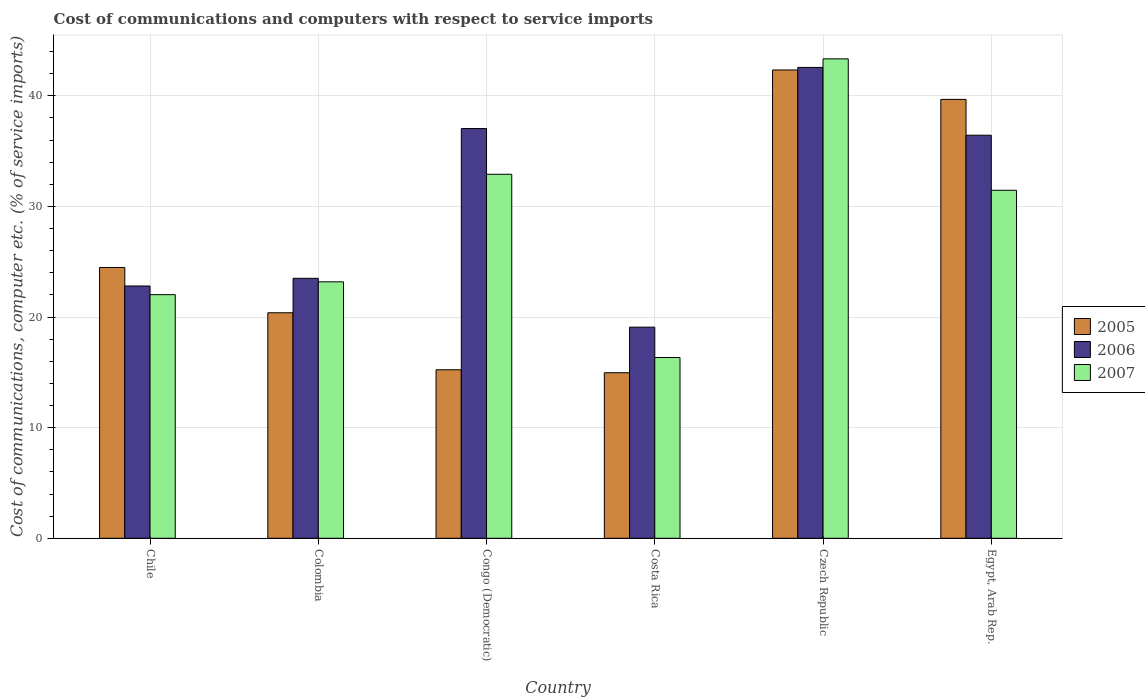How many groups of bars are there?
Keep it short and to the point. 6. Are the number of bars on each tick of the X-axis equal?
Offer a terse response. Yes. How many bars are there on the 6th tick from the left?
Give a very brief answer. 3. How many bars are there on the 1st tick from the right?
Your answer should be very brief. 3. In how many cases, is the number of bars for a given country not equal to the number of legend labels?
Offer a terse response. 0. What is the cost of communications and computers in 2007 in Costa Rica?
Your answer should be very brief. 16.34. Across all countries, what is the maximum cost of communications and computers in 2006?
Your answer should be very brief. 42.56. Across all countries, what is the minimum cost of communications and computers in 2007?
Keep it short and to the point. 16.34. In which country was the cost of communications and computers in 2005 maximum?
Offer a very short reply. Czech Republic. What is the total cost of communications and computers in 2006 in the graph?
Your answer should be compact. 181.43. What is the difference between the cost of communications and computers in 2007 in Congo (Democratic) and that in Costa Rica?
Offer a terse response. 16.56. What is the difference between the cost of communications and computers in 2007 in Congo (Democratic) and the cost of communications and computers in 2005 in Costa Rica?
Keep it short and to the point. 17.94. What is the average cost of communications and computers in 2007 per country?
Offer a very short reply. 28.21. What is the difference between the cost of communications and computers of/in 2007 and cost of communications and computers of/in 2006 in Congo (Democratic)?
Your response must be concise. -4.13. What is the ratio of the cost of communications and computers in 2006 in Colombia to that in Congo (Democratic)?
Provide a short and direct response. 0.63. What is the difference between the highest and the second highest cost of communications and computers in 2005?
Your response must be concise. -17.85. What is the difference between the highest and the lowest cost of communications and computers in 2006?
Your answer should be very brief. 23.48. In how many countries, is the cost of communications and computers in 2007 greater than the average cost of communications and computers in 2007 taken over all countries?
Keep it short and to the point. 3. What does the 1st bar from the left in Chile represents?
Offer a very short reply. 2005. What does the 1st bar from the right in Egypt, Arab Rep. represents?
Give a very brief answer. 2007. Is it the case that in every country, the sum of the cost of communications and computers in 2007 and cost of communications and computers in 2005 is greater than the cost of communications and computers in 2006?
Your response must be concise. Yes. How many bars are there?
Provide a succinct answer. 18. Are all the bars in the graph horizontal?
Provide a short and direct response. No. Are the values on the major ticks of Y-axis written in scientific E-notation?
Offer a very short reply. No. Does the graph contain any zero values?
Provide a short and direct response. No. Does the graph contain grids?
Provide a short and direct response. Yes. Where does the legend appear in the graph?
Provide a short and direct response. Center right. How many legend labels are there?
Keep it short and to the point. 3. What is the title of the graph?
Give a very brief answer. Cost of communications and computers with respect to service imports. What is the label or title of the Y-axis?
Make the answer very short. Cost of communications, computer etc. (% of service imports). What is the Cost of communications, computer etc. (% of service imports) of 2005 in Chile?
Your answer should be very brief. 24.48. What is the Cost of communications, computer etc. (% of service imports) in 2006 in Chile?
Provide a short and direct response. 22.81. What is the Cost of communications, computer etc. (% of service imports) of 2007 in Chile?
Your answer should be very brief. 22.02. What is the Cost of communications, computer etc. (% of service imports) of 2005 in Colombia?
Offer a very short reply. 20.39. What is the Cost of communications, computer etc. (% of service imports) of 2006 in Colombia?
Offer a very short reply. 23.5. What is the Cost of communications, computer etc. (% of service imports) of 2007 in Colombia?
Provide a short and direct response. 23.18. What is the Cost of communications, computer etc. (% of service imports) of 2005 in Congo (Democratic)?
Your answer should be very brief. 15.23. What is the Cost of communications, computer etc. (% of service imports) of 2006 in Congo (Democratic)?
Ensure brevity in your answer.  37.04. What is the Cost of communications, computer etc. (% of service imports) in 2007 in Congo (Democratic)?
Your answer should be very brief. 32.91. What is the Cost of communications, computer etc. (% of service imports) of 2005 in Costa Rica?
Your answer should be compact. 14.97. What is the Cost of communications, computer etc. (% of service imports) of 2006 in Costa Rica?
Keep it short and to the point. 19.09. What is the Cost of communications, computer etc. (% of service imports) in 2007 in Costa Rica?
Your answer should be compact. 16.34. What is the Cost of communications, computer etc. (% of service imports) in 2005 in Czech Republic?
Your response must be concise. 42.33. What is the Cost of communications, computer etc. (% of service imports) of 2006 in Czech Republic?
Make the answer very short. 42.56. What is the Cost of communications, computer etc. (% of service imports) of 2007 in Czech Republic?
Keep it short and to the point. 43.34. What is the Cost of communications, computer etc. (% of service imports) of 2005 in Egypt, Arab Rep.?
Keep it short and to the point. 39.68. What is the Cost of communications, computer etc. (% of service imports) in 2006 in Egypt, Arab Rep.?
Keep it short and to the point. 36.44. What is the Cost of communications, computer etc. (% of service imports) in 2007 in Egypt, Arab Rep.?
Your answer should be compact. 31.46. Across all countries, what is the maximum Cost of communications, computer etc. (% of service imports) in 2005?
Ensure brevity in your answer.  42.33. Across all countries, what is the maximum Cost of communications, computer etc. (% of service imports) of 2006?
Give a very brief answer. 42.56. Across all countries, what is the maximum Cost of communications, computer etc. (% of service imports) of 2007?
Provide a succinct answer. 43.34. Across all countries, what is the minimum Cost of communications, computer etc. (% of service imports) of 2005?
Offer a terse response. 14.97. Across all countries, what is the minimum Cost of communications, computer etc. (% of service imports) of 2006?
Keep it short and to the point. 19.09. Across all countries, what is the minimum Cost of communications, computer etc. (% of service imports) of 2007?
Your answer should be very brief. 16.34. What is the total Cost of communications, computer etc. (% of service imports) in 2005 in the graph?
Offer a very short reply. 157.08. What is the total Cost of communications, computer etc. (% of service imports) of 2006 in the graph?
Provide a succinct answer. 181.43. What is the total Cost of communications, computer etc. (% of service imports) in 2007 in the graph?
Keep it short and to the point. 169.26. What is the difference between the Cost of communications, computer etc. (% of service imports) of 2005 in Chile and that in Colombia?
Provide a short and direct response. 4.09. What is the difference between the Cost of communications, computer etc. (% of service imports) in 2006 in Chile and that in Colombia?
Provide a succinct answer. -0.69. What is the difference between the Cost of communications, computer etc. (% of service imports) in 2007 in Chile and that in Colombia?
Keep it short and to the point. -1.16. What is the difference between the Cost of communications, computer etc. (% of service imports) in 2005 in Chile and that in Congo (Democratic)?
Provide a succinct answer. 9.25. What is the difference between the Cost of communications, computer etc. (% of service imports) of 2006 in Chile and that in Congo (Democratic)?
Give a very brief answer. -14.23. What is the difference between the Cost of communications, computer etc. (% of service imports) in 2007 in Chile and that in Congo (Democratic)?
Your response must be concise. -10.88. What is the difference between the Cost of communications, computer etc. (% of service imports) of 2005 in Chile and that in Costa Rica?
Your answer should be very brief. 9.52. What is the difference between the Cost of communications, computer etc. (% of service imports) of 2006 in Chile and that in Costa Rica?
Give a very brief answer. 3.72. What is the difference between the Cost of communications, computer etc. (% of service imports) of 2007 in Chile and that in Costa Rica?
Offer a very short reply. 5.68. What is the difference between the Cost of communications, computer etc. (% of service imports) in 2005 in Chile and that in Czech Republic?
Offer a terse response. -17.85. What is the difference between the Cost of communications, computer etc. (% of service imports) of 2006 in Chile and that in Czech Republic?
Offer a terse response. -19.76. What is the difference between the Cost of communications, computer etc. (% of service imports) of 2007 in Chile and that in Czech Republic?
Give a very brief answer. -21.32. What is the difference between the Cost of communications, computer etc. (% of service imports) of 2005 in Chile and that in Egypt, Arab Rep.?
Ensure brevity in your answer.  -15.19. What is the difference between the Cost of communications, computer etc. (% of service imports) in 2006 in Chile and that in Egypt, Arab Rep.?
Offer a terse response. -13.63. What is the difference between the Cost of communications, computer etc. (% of service imports) of 2007 in Chile and that in Egypt, Arab Rep.?
Your answer should be very brief. -9.44. What is the difference between the Cost of communications, computer etc. (% of service imports) in 2005 in Colombia and that in Congo (Democratic)?
Offer a terse response. 5.15. What is the difference between the Cost of communications, computer etc. (% of service imports) in 2006 in Colombia and that in Congo (Democratic)?
Make the answer very short. -13.54. What is the difference between the Cost of communications, computer etc. (% of service imports) of 2007 in Colombia and that in Congo (Democratic)?
Provide a short and direct response. -9.72. What is the difference between the Cost of communications, computer etc. (% of service imports) of 2005 in Colombia and that in Costa Rica?
Make the answer very short. 5.42. What is the difference between the Cost of communications, computer etc. (% of service imports) of 2006 in Colombia and that in Costa Rica?
Give a very brief answer. 4.41. What is the difference between the Cost of communications, computer etc. (% of service imports) in 2007 in Colombia and that in Costa Rica?
Give a very brief answer. 6.84. What is the difference between the Cost of communications, computer etc. (% of service imports) of 2005 in Colombia and that in Czech Republic?
Give a very brief answer. -21.95. What is the difference between the Cost of communications, computer etc. (% of service imports) in 2006 in Colombia and that in Czech Republic?
Ensure brevity in your answer.  -19.06. What is the difference between the Cost of communications, computer etc. (% of service imports) of 2007 in Colombia and that in Czech Republic?
Your response must be concise. -20.16. What is the difference between the Cost of communications, computer etc. (% of service imports) in 2005 in Colombia and that in Egypt, Arab Rep.?
Your answer should be compact. -19.29. What is the difference between the Cost of communications, computer etc. (% of service imports) of 2006 in Colombia and that in Egypt, Arab Rep.?
Make the answer very short. -12.94. What is the difference between the Cost of communications, computer etc. (% of service imports) in 2007 in Colombia and that in Egypt, Arab Rep.?
Your answer should be very brief. -8.28. What is the difference between the Cost of communications, computer etc. (% of service imports) in 2005 in Congo (Democratic) and that in Costa Rica?
Offer a terse response. 0.27. What is the difference between the Cost of communications, computer etc. (% of service imports) in 2006 in Congo (Democratic) and that in Costa Rica?
Offer a terse response. 17.95. What is the difference between the Cost of communications, computer etc. (% of service imports) of 2007 in Congo (Democratic) and that in Costa Rica?
Keep it short and to the point. 16.56. What is the difference between the Cost of communications, computer etc. (% of service imports) in 2005 in Congo (Democratic) and that in Czech Republic?
Provide a succinct answer. -27.1. What is the difference between the Cost of communications, computer etc. (% of service imports) of 2006 in Congo (Democratic) and that in Czech Republic?
Provide a short and direct response. -5.53. What is the difference between the Cost of communications, computer etc. (% of service imports) of 2007 in Congo (Democratic) and that in Czech Republic?
Offer a very short reply. -10.43. What is the difference between the Cost of communications, computer etc. (% of service imports) in 2005 in Congo (Democratic) and that in Egypt, Arab Rep.?
Provide a succinct answer. -24.44. What is the difference between the Cost of communications, computer etc. (% of service imports) of 2006 in Congo (Democratic) and that in Egypt, Arab Rep.?
Your response must be concise. 0.6. What is the difference between the Cost of communications, computer etc. (% of service imports) in 2007 in Congo (Democratic) and that in Egypt, Arab Rep.?
Your answer should be very brief. 1.45. What is the difference between the Cost of communications, computer etc. (% of service imports) in 2005 in Costa Rica and that in Czech Republic?
Keep it short and to the point. -27.37. What is the difference between the Cost of communications, computer etc. (% of service imports) in 2006 in Costa Rica and that in Czech Republic?
Make the answer very short. -23.48. What is the difference between the Cost of communications, computer etc. (% of service imports) of 2007 in Costa Rica and that in Czech Republic?
Your response must be concise. -27. What is the difference between the Cost of communications, computer etc. (% of service imports) in 2005 in Costa Rica and that in Egypt, Arab Rep.?
Your answer should be compact. -24.71. What is the difference between the Cost of communications, computer etc. (% of service imports) of 2006 in Costa Rica and that in Egypt, Arab Rep.?
Your response must be concise. -17.35. What is the difference between the Cost of communications, computer etc. (% of service imports) of 2007 in Costa Rica and that in Egypt, Arab Rep.?
Your response must be concise. -15.12. What is the difference between the Cost of communications, computer etc. (% of service imports) of 2005 in Czech Republic and that in Egypt, Arab Rep.?
Ensure brevity in your answer.  2.66. What is the difference between the Cost of communications, computer etc. (% of service imports) in 2006 in Czech Republic and that in Egypt, Arab Rep.?
Ensure brevity in your answer.  6.13. What is the difference between the Cost of communications, computer etc. (% of service imports) of 2007 in Czech Republic and that in Egypt, Arab Rep.?
Keep it short and to the point. 11.88. What is the difference between the Cost of communications, computer etc. (% of service imports) in 2005 in Chile and the Cost of communications, computer etc. (% of service imports) in 2006 in Colombia?
Provide a succinct answer. 0.98. What is the difference between the Cost of communications, computer etc. (% of service imports) of 2005 in Chile and the Cost of communications, computer etc. (% of service imports) of 2007 in Colombia?
Offer a terse response. 1.3. What is the difference between the Cost of communications, computer etc. (% of service imports) in 2006 in Chile and the Cost of communications, computer etc. (% of service imports) in 2007 in Colombia?
Provide a short and direct response. -0.38. What is the difference between the Cost of communications, computer etc. (% of service imports) in 2005 in Chile and the Cost of communications, computer etc. (% of service imports) in 2006 in Congo (Democratic)?
Offer a terse response. -12.56. What is the difference between the Cost of communications, computer etc. (% of service imports) in 2005 in Chile and the Cost of communications, computer etc. (% of service imports) in 2007 in Congo (Democratic)?
Provide a short and direct response. -8.43. What is the difference between the Cost of communications, computer etc. (% of service imports) in 2006 in Chile and the Cost of communications, computer etc. (% of service imports) in 2007 in Congo (Democratic)?
Provide a succinct answer. -10.1. What is the difference between the Cost of communications, computer etc. (% of service imports) in 2005 in Chile and the Cost of communications, computer etc. (% of service imports) in 2006 in Costa Rica?
Your answer should be compact. 5.4. What is the difference between the Cost of communications, computer etc. (% of service imports) of 2005 in Chile and the Cost of communications, computer etc. (% of service imports) of 2007 in Costa Rica?
Offer a terse response. 8.14. What is the difference between the Cost of communications, computer etc. (% of service imports) in 2006 in Chile and the Cost of communications, computer etc. (% of service imports) in 2007 in Costa Rica?
Your response must be concise. 6.46. What is the difference between the Cost of communications, computer etc. (% of service imports) in 2005 in Chile and the Cost of communications, computer etc. (% of service imports) in 2006 in Czech Republic?
Give a very brief answer. -18.08. What is the difference between the Cost of communications, computer etc. (% of service imports) of 2005 in Chile and the Cost of communications, computer etc. (% of service imports) of 2007 in Czech Republic?
Provide a succinct answer. -18.86. What is the difference between the Cost of communications, computer etc. (% of service imports) in 2006 in Chile and the Cost of communications, computer etc. (% of service imports) in 2007 in Czech Republic?
Your answer should be compact. -20.53. What is the difference between the Cost of communications, computer etc. (% of service imports) in 2005 in Chile and the Cost of communications, computer etc. (% of service imports) in 2006 in Egypt, Arab Rep.?
Provide a succinct answer. -11.96. What is the difference between the Cost of communications, computer etc. (% of service imports) in 2005 in Chile and the Cost of communications, computer etc. (% of service imports) in 2007 in Egypt, Arab Rep.?
Your answer should be compact. -6.98. What is the difference between the Cost of communications, computer etc. (% of service imports) of 2006 in Chile and the Cost of communications, computer etc. (% of service imports) of 2007 in Egypt, Arab Rep.?
Your answer should be compact. -8.65. What is the difference between the Cost of communications, computer etc. (% of service imports) of 2005 in Colombia and the Cost of communications, computer etc. (% of service imports) of 2006 in Congo (Democratic)?
Ensure brevity in your answer.  -16.65. What is the difference between the Cost of communications, computer etc. (% of service imports) of 2005 in Colombia and the Cost of communications, computer etc. (% of service imports) of 2007 in Congo (Democratic)?
Offer a terse response. -12.52. What is the difference between the Cost of communications, computer etc. (% of service imports) of 2006 in Colombia and the Cost of communications, computer etc. (% of service imports) of 2007 in Congo (Democratic)?
Keep it short and to the point. -9.41. What is the difference between the Cost of communications, computer etc. (% of service imports) in 2005 in Colombia and the Cost of communications, computer etc. (% of service imports) in 2006 in Costa Rica?
Ensure brevity in your answer.  1.3. What is the difference between the Cost of communications, computer etc. (% of service imports) in 2005 in Colombia and the Cost of communications, computer etc. (% of service imports) in 2007 in Costa Rica?
Give a very brief answer. 4.04. What is the difference between the Cost of communications, computer etc. (% of service imports) in 2006 in Colombia and the Cost of communications, computer etc. (% of service imports) in 2007 in Costa Rica?
Your answer should be very brief. 7.16. What is the difference between the Cost of communications, computer etc. (% of service imports) in 2005 in Colombia and the Cost of communications, computer etc. (% of service imports) in 2006 in Czech Republic?
Make the answer very short. -22.18. What is the difference between the Cost of communications, computer etc. (% of service imports) of 2005 in Colombia and the Cost of communications, computer etc. (% of service imports) of 2007 in Czech Republic?
Ensure brevity in your answer.  -22.95. What is the difference between the Cost of communications, computer etc. (% of service imports) in 2006 in Colombia and the Cost of communications, computer etc. (% of service imports) in 2007 in Czech Republic?
Your answer should be very brief. -19.84. What is the difference between the Cost of communications, computer etc. (% of service imports) in 2005 in Colombia and the Cost of communications, computer etc. (% of service imports) in 2006 in Egypt, Arab Rep.?
Give a very brief answer. -16.05. What is the difference between the Cost of communications, computer etc. (% of service imports) of 2005 in Colombia and the Cost of communications, computer etc. (% of service imports) of 2007 in Egypt, Arab Rep.?
Your answer should be very brief. -11.07. What is the difference between the Cost of communications, computer etc. (% of service imports) in 2006 in Colombia and the Cost of communications, computer etc. (% of service imports) in 2007 in Egypt, Arab Rep.?
Your response must be concise. -7.96. What is the difference between the Cost of communications, computer etc. (% of service imports) in 2005 in Congo (Democratic) and the Cost of communications, computer etc. (% of service imports) in 2006 in Costa Rica?
Your answer should be compact. -3.85. What is the difference between the Cost of communications, computer etc. (% of service imports) of 2005 in Congo (Democratic) and the Cost of communications, computer etc. (% of service imports) of 2007 in Costa Rica?
Keep it short and to the point. -1.11. What is the difference between the Cost of communications, computer etc. (% of service imports) in 2006 in Congo (Democratic) and the Cost of communications, computer etc. (% of service imports) in 2007 in Costa Rica?
Provide a succinct answer. 20.7. What is the difference between the Cost of communications, computer etc. (% of service imports) of 2005 in Congo (Democratic) and the Cost of communications, computer etc. (% of service imports) of 2006 in Czech Republic?
Your answer should be compact. -27.33. What is the difference between the Cost of communications, computer etc. (% of service imports) of 2005 in Congo (Democratic) and the Cost of communications, computer etc. (% of service imports) of 2007 in Czech Republic?
Ensure brevity in your answer.  -28.11. What is the difference between the Cost of communications, computer etc. (% of service imports) of 2006 in Congo (Democratic) and the Cost of communications, computer etc. (% of service imports) of 2007 in Czech Republic?
Your answer should be very brief. -6.3. What is the difference between the Cost of communications, computer etc. (% of service imports) in 2005 in Congo (Democratic) and the Cost of communications, computer etc. (% of service imports) in 2006 in Egypt, Arab Rep.?
Keep it short and to the point. -21.2. What is the difference between the Cost of communications, computer etc. (% of service imports) of 2005 in Congo (Democratic) and the Cost of communications, computer etc. (% of service imports) of 2007 in Egypt, Arab Rep.?
Give a very brief answer. -16.23. What is the difference between the Cost of communications, computer etc. (% of service imports) of 2006 in Congo (Democratic) and the Cost of communications, computer etc. (% of service imports) of 2007 in Egypt, Arab Rep.?
Ensure brevity in your answer.  5.58. What is the difference between the Cost of communications, computer etc. (% of service imports) in 2005 in Costa Rica and the Cost of communications, computer etc. (% of service imports) in 2006 in Czech Republic?
Your response must be concise. -27.6. What is the difference between the Cost of communications, computer etc. (% of service imports) in 2005 in Costa Rica and the Cost of communications, computer etc. (% of service imports) in 2007 in Czech Republic?
Offer a very short reply. -28.38. What is the difference between the Cost of communications, computer etc. (% of service imports) of 2006 in Costa Rica and the Cost of communications, computer etc. (% of service imports) of 2007 in Czech Republic?
Offer a very short reply. -24.26. What is the difference between the Cost of communications, computer etc. (% of service imports) in 2005 in Costa Rica and the Cost of communications, computer etc. (% of service imports) in 2006 in Egypt, Arab Rep.?
Provide a short and direct response. -21.47. What is the difference between the Cost of communications, computer etc. (% of service imports) in 2005 in Costa Rica and the Cost of communications, computer etc. (% of service imports) in 2007 in Egypt, Arab Rep.?
Your answer should be compact. -16.49. What is the difference between the Cost of communications, computer etc. (% of service imports) in 2006 in Costa Rica and the Cost of communications, computer etc. (% of service imports) in 2007 in Egypt, Arab Rep.?
Ensure brevity in your answer.  -12.37. What is the difference between the Cost of communications, computer etc. (% of service imports) in 2005 in Czech Republic and the Cost of communications, computer etc. (% of service imports) in 2006 in Egypt, Arab Rep.?
Ensure brevity in your answer.  5.9. What is the difference between the Cost of communications, computer etc. (% of service imports) in 2005 in Czech Republic and the Cost of communications, computer etc. (% of service imports) in 2007 in Egypt, Arab Rep.?
Make the answer very short. 10.88. What is the difference between the Cost of communications, computer etc. (% of service imports) of 2006 in Czech Republic and the Cost of communications, computer etc. (% of service imports) of 2007 in Egypt, Arab Rep.?
Ensure brevity in your answer.  11.1. What is the average Cost of communications, computer etc. (% of service imports) in 2005 per country?
Your answer should be very brief. 26.18. What is the average Cost of communications, computer etc. (% of service imports) in 2006 per country?
Offer a very short reply. 30.24. What is the average Cost of communications, computer etc. (% of service imports) of 2007 per country?
Ensure brevity in your answer.  28.21. What is the difference between the Cost of communications, computer etc. (% of service imports) of 2005 and Cost of communications, computer etc. (% of service imports) of 2006 in Chile?
Keep it short and to the point. 1.67. What is the difference between the Cost of communications, computer etc. (% of service imports) in 2005 and Cost of communications, computer etc. (% of service imports) in 2007 in Chile?
Offer a very short reply. 2.46. What is the difference between the Cost of communications, computer etc. (% of service imports) of 2006 and Cost of communications, computer etc. (% of service imports) of 2007 in Chile?
Offer a terse response. 0.78. What is the difference between the Cost of communications, computer etc. (% of service imports) in 2005 and Cost of communications, computer etc. (% of service imports) in 2006 in Colombia?
Offer a terse response. -3.11. What is the difference between the Cost of communications, computer etc. (% of service imports) in 2005 and Cost of communications, computer etc. (% of service imports) in 2007 in Colombia?
Offer a terse response. -2.8. What is the difference between the Cost of communications, computer etc. (% of service imports) of 2006 and Cost of communications, computer etc. (% of service imports) of 2007 in Colombia?
Keep it short and to the point. 0.32. What is the difference between the Cost of communications, computer etc. (% of service imports) in 2005 and Cost of communications, computer etc. (% of service imports) in 2006 in Congo (Democratic)?
Provide a short and direct response. -21.81. What is the difference between the Cost of communications, computer etc. (% of service imports) in 2005 and Cost of communications, computer etc. (% of service imports) in 2007 in Congo (Democratic)?
Give a very brief answer. -17.67. What is the difference between the Cost of communications, computer etc. (% of service imports) of 2006 and Cost of communications, computer etc. (% of service imports) of 2007 in Congo (Democratic)?
Make the answer very short. 4.13. What is the difference between the Cost of communications, computer etc. (% of service imports) in 2005 and Cost of communications, computer etc. (% of service imports) in 2006 in Costa Rica?
Your answer should be compact. -4.12. What is the difference between the Cost of communications, computer etc. (% of service imports) in 2005 and Cost of communications, computer etc. (% of service imports) in 2007 in Costa Rica?
Your answer should be compact. -1.38. What is the difference between the Cost of communications, computer etc. (% of service imports) of 2006 and Cost of communications, computer etc. (% of service imports) of 2007 in Costa Rica?
Offer a very short reply. 2.74. What is the difference between the Cost of communications, computer etc. (% of service imports) of 2005 and Cost of communications, computer etc. (% of service imports) of 2006 in Czech Republic?
Provide a succinct answer. -0.23. What is the difference between the Cost of communications, computer etc. (% of service imports) in 2005 and Cost of communications, computer etc. (% of service imports) in 2007 in Czech Republic?
Provide a succinct answer. -1.01. What is the difference between the Cost of communications, computer etc. (% of service imports) in 2006 and Cost of communications, computer etc. (% of service imports) in 2007 in Czech Republic?
Make the answer very short. -0.78. What is the difference between the Cost of communications, computer etc. (% of service imports) in 2005 and Cost of communications, computer etc. (% of service imports) in 2006 in Egypt, Arab Rep.?
Keep it short and to the point. 3.24. What is the difference between the Cost of communications, computer etc. (% of service imports) in 2005 and Cost of communications, computer etc. (% of service imports) in 2007 in Egypt, Arab Rep.?
Your answer should be very brief. 8.22. What is the difference between the Cost of communications, computer etc. (% of service imports) in 2006 and Cost of communications, computer etc. (% of service imports) in 2007 in Egypt, Arab Rep.?
Give a very brief answer. 4.98. What is the ratio of the Cost of communications, computer etc. (% of service imports) in 2005 in Chile to that in Colombia?
Offer a terse response. 1.2. What is the ratio of the Cost of communications, computer etc. (% of service imports) of 2006 in Chile to that in Colombia?
Ensure brevity in your answer.  0.97. What is the ratio of the Cost of communications, computer etc. (% of service imports) in 2005 in Chile to that in Congo (Democratic)?
Give a very brief answer. 1.61. What is the ratio of the Cost of communications, computer etc. (% of service imports) in 2006 in Chile to that in Congo (Democratic)?
Your response must be concise. 0.62. What is the ratio of the Cost of communications, computer etc. (% of service imports) of 2007 in Chile to that in Congo (Democratic)?
Offer a terse response. 0.67. What is the ratio of the Cost of communications, computer etc. (% of service imports) in 2005 in Chile to that in Costa Rica?
Keep it short and to the point. 1.64. What is the ratio of the Cost of communications, computer etc. (% of service imports) of 2006 in Chile to that in Costa Rica?
Provide a succinct answer. 1.2. What is the ratio of the Cost of communications, computer etc. (% of service imports) in 2007 in Chile to that in Costa Rica?
Provide a short and direct response. 1.35. What is the ratio of the Cost of communications, computer etc. (% of service imports) in 2005 in Chile to that in Czech Republic?
Your answer should be very brief. 0.58. What is the ratio of the Cost of communications, computer etc. (% of service imports) in 2006 in Chile to that in Czech Republic?
Offer a terse response. 0.54. What is the ratio of the Cost of communications, computer etc. (% of service imports) of 2007 in Chile to that in Czech Republic?
Give a very brief answer. 0.51. What is the ratio of the Cost of communications, computer etc. (% of service imports) of 2005 in Chile to that in Egypt, Arab Rep.?
Offer a terse response. 0.62. What is the ratio of the Cost of communications, computer etc. (% of service imports) of 2006 in Chile to that in Egypt, Arab Rep.?
Your response must be concise. 0.63. What is the ratio of the Cost of communications, computer etc. (% of service imports) in 2007 in Chile to that in Egypt, Arab Rep.?
Your answer should be very brief. 0.7. What is the ratio of the Cost of communications, computer etc. (% of service imports) in 2005 in Colombia to that in Congo (Democratic)?
Ensure brevity in your answer.  1.34. What is the ratio of the Cost of communications, computer etc. (% of service imports) of 2006 in Colombia to that in Congo (Democratic)?
Make the answer very short. 0.63. What is the ratio of the Cost of communications, computer etc. (% of service imports) in 2007 in Colombia to that in Congo (Democratic)?
Ensure brevity in your answer.  0.7. What is the ratio of the Cost of communications, computer etc. (% of service imports) of 2005 in Colombia to that in Costa Rica?
Make the answer very short. 1.36. What is the ratio of the Cost of communications, computer etc. (% of service imports) in 2006 in Colombia to that in Costa Rica?
Your answer should be very brief. 1.23. What is the ratio of the Cost of communications, computer etc. (% of service imports) of 2007 in Colombia to that in Costa Rica?
Give a very brief answer. 1.42. What is the ratio of the Cost of communications, computer etc. (% of service imports) in 2005 in Colombia to that in Czech Republic?
Your answer should be compact. 0.48. What is the ratio of the Cost of communications, computer etc. (% of service imports) of 2006 in Colombia to that in Czech Republic?
Keep it short and to the point. 0.55. What is the ratio of the Cost of communications, computer etc. (% of service imports) of 2007 in Colombia to that in Czech Republic?
Make the answer very short. 0.53. What is the ratio of the Cost of communications, computer etc. (% of service imports) of 2005 in Colombia to that in Egypt, Arab Rep.?
Your answer should be very brief. 0.51. What is the ratio of the Cost of communications, computer etc. (% of service imports) of 2006 in Colombia to that in Egypt, Arab Rep.?
Keep it short and to the point. 0.64. What is the ratio of the Cost of communications, computer etc. (% of service imports) in 2007 in Colombia to that in Egypt, Arab Rep.?
Ensure brevity in your answer.  0.74. What is the ratio of the Cost of communications, computer etc. (% of service imports) of 2005 in Congo (Democratic) to that in Costa Rica?
Ensure brevity in your answer.  1.02. What is the ratio of the Cost of communications, computer etc. (% of service imports) in 2006 in Congo (Democratic) to that in Costa Rica?
Offer a very short reply. 1.94. What is the ratio of the Cost of communications, computer etc. (% of service imports) in 2007 in Congo (Democratic) to that in Costa Rica?
Make the answer very short. 2.01. What is the ratio of the Cost of communications, computer etc. (% of service imports) of 2005 in Congo (Democratic) to that in Czech Republic?
Offer a terse response. 0.36. What is the ratio of the Cost of communications, computer etc. (% of service imports) in 2006 in Congo (Democratic) to that in Czech Republic?
Ensure brevity in your answer.  0.87. What is the ratio of the Cost of communications, computer etc. (% of service imports) in 2007 in Congo (Democratic) to that in Czech Republic?
Give a very brief answer. 0.76. What is the ratio of the Cost of communications, computer etc. (% of service imports) of 2005 in Congo (Democratic) to that in Egypt, Arab Rep.?
Offer a very short reply. 0.38. What is the ratio of the Cost of communications, computer etc. (% of service imports) of 2006 in Congo (Democratic) to that in Egypt, Arab Rep.?
Your response must be concise. 1.02. What is the ratio of the Cost of communications, computer etc. (% of service imports) in 2007 in Congo (Democratic) to that in Egypt, Arab Rep.?
Your answer should be compact. 1.05. What is the ratio of the Cost of communications, computer etc. (% of service imports) in 2005 in Costa Rica to that in Czech Republic?
Offer a terse response. 0.35. What is the ratio of the Cost of communications, computer etc. (% of service imports) in 2006 in Costa Rica to that in Czech Republic?
Give a very brief answer. 0.45. What is the ratio of the Cost of communications, computer etc. (% of service imports) in 2007 in Costa Rica to that in Czech Republic?
Make the answer very short. 0.38. What is the ratio of the Cost of communications, computer etc. (% of service imports) in 2005 in Costa Rica to that in Egypt, Arab Rep.?
Your response must be concise. 0.38. What is the ratio of the Cost of communications, computer etc. (% of service imports) of 2006 in Costa Rica to that in Egypt, Arab Rep.?
Provide a succinct answer. 0.52. What is the ratio of the Cost of communications, computer etc. (% of service imports) in 2007 in Costa Rica to that in Egypt, Arab Rep.?
Give a very brief answer. 0.52. What is the ratio of the Cost of communications, computer etc. (% of service imports) of 2005 in Czech Republic to that in Egypt, Arab Rep.?
Make the answer very short. 1.07. What is the ratio of the Cost of communications, computer etc. (% of service imports) of 2006 in Czech Republic to that in Egypt, Arab Rep.?
Keep it short and to the point. 1.17. What is the ratio of the Cost of communications, computer etc. (% of service imports) in 2007 in Czech Republic to that in Egypt, Arab Rep.?
Ensure brevity in your answer.  1.38. What is the difference between the highest and the second highest Cost of communications, computer etc. (% of service imports) of 2005?
Give a very brief answer. 2.66. What is the difference between the highest and the second highest Cost of communications, computer etc. (% of service imports) in 2006?
Keep it short and to the point. 5.53. What is the difference between the highest and the second highest Cost of communications, computer etc. (% of service imports) in 2007?
Offer a terse response. 10.43. What is the difference between the highest and the lowest Cost of communications, computer etc. (% of service imports) of 2005?
Ensure brevity in your answer.  27.37. What is the difference between the highest and the lowest Cost of communications, computer etc. (% of service imports) in 2006?
Your response must be concise. 23.48. What is the difference between the highest and the lowest Cost of communications, computer etc. (% of service imports) in 2007?
Your response must be concise. 27. 